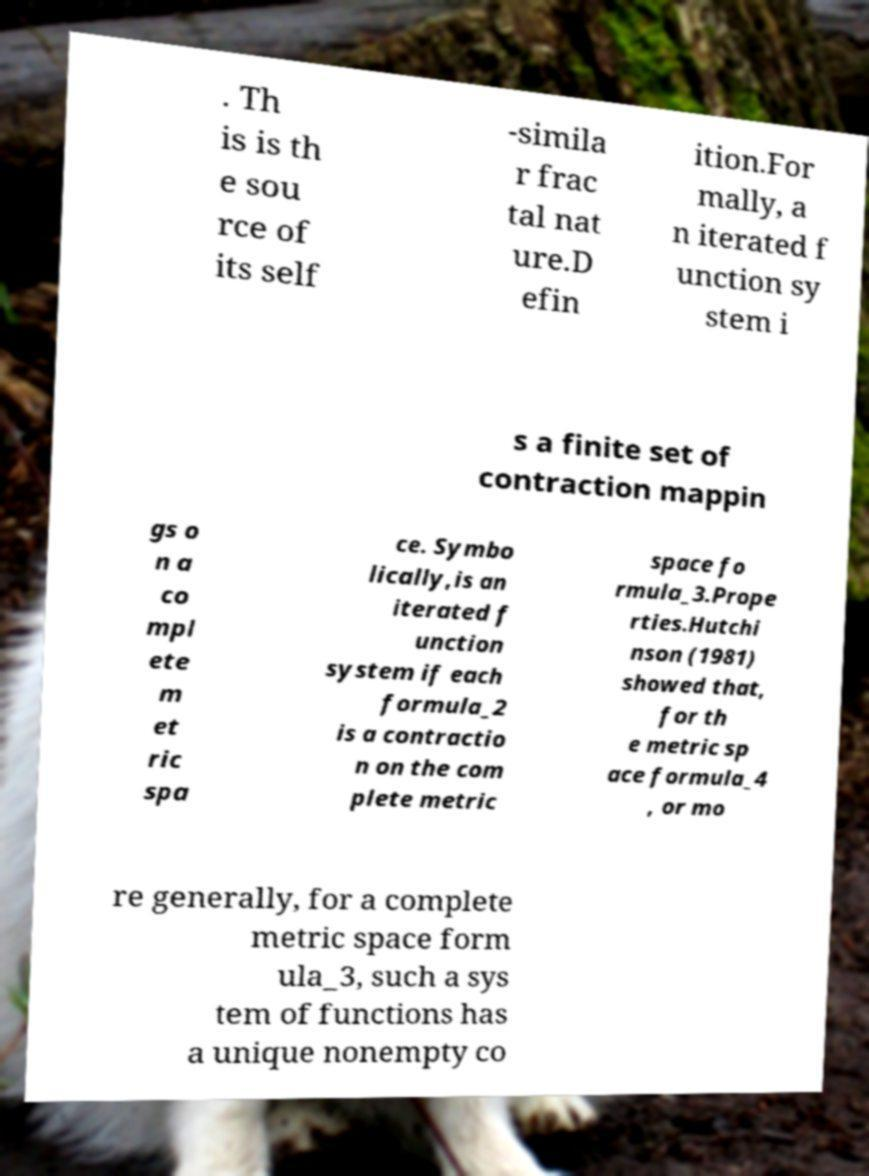There's text embedded in this image that I need extracted. Can you transcribe it verbatim? . Th is is th e sou rce of its self -simila r frac tal nat ure.D efin ition.For mally, a n iterated f unction sy stem i s a finite set of contraction mappin gs o n a co mpl ete m et ric spa ce. Symbo lically,is an iterated f unction system if each formula_2 is a contractio n on the com plete metric space fo rmula_3.Prope rties.Hutchi nson (1981) showed that, for th e metric sp ace formula_4 , or mo re generally, for a complete metric space form ula_3, such a sys tem of functions has a unique nonempty co 